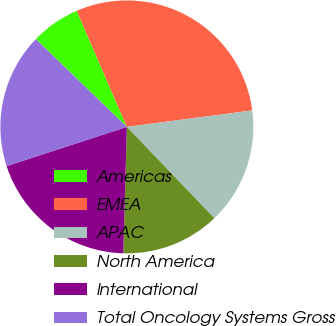Convert chart to OTSL. <chart><loc_0><loc_0><loc_500><loc_500><pie_chart><fcel>Americas<fcel>EMEA<fcel>APAC<fcel>North America<fcel>International<fcel>Total Oncology Systems Gross<nl><fcel>6.3%<fcel>29.41%<fcel>14.92%<fcel>12.61%<fcel>19.54%<fcel>17.23%<nl></chart> 